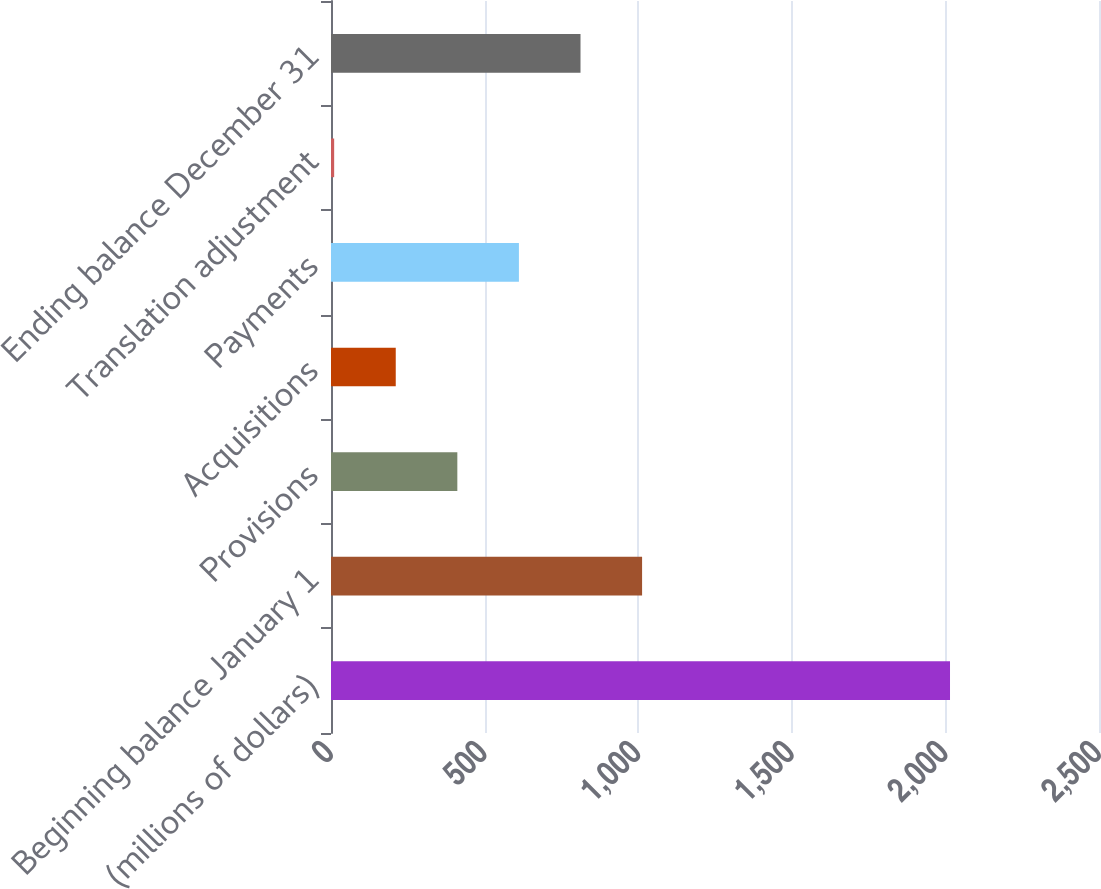Convert chart to OTSL. <chart><loc_0><loc_0><loc_500><loc_500><bar_chart><fcel>(millions of dollars)<fcel>Beginning balance January 1<fcel>Provisions<fcel>Acquisitions<fcel>Payments<fcel>Translation adjustment<fcel>Ending balance December 31<nl><fcel>2015<fcel>1012.65<fcel>411.24<fcel>210.77<fcel>611.71<fcel>10.3<fcel>812.18<nl></chart> 